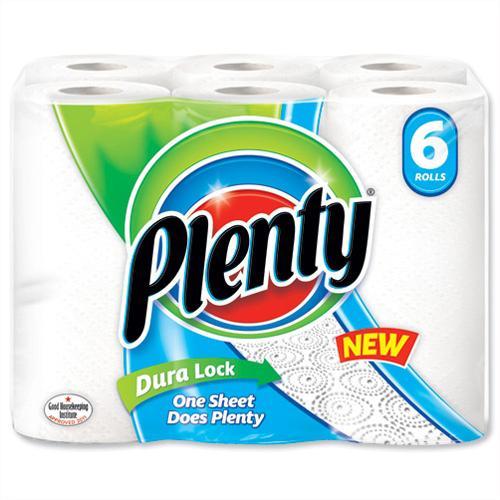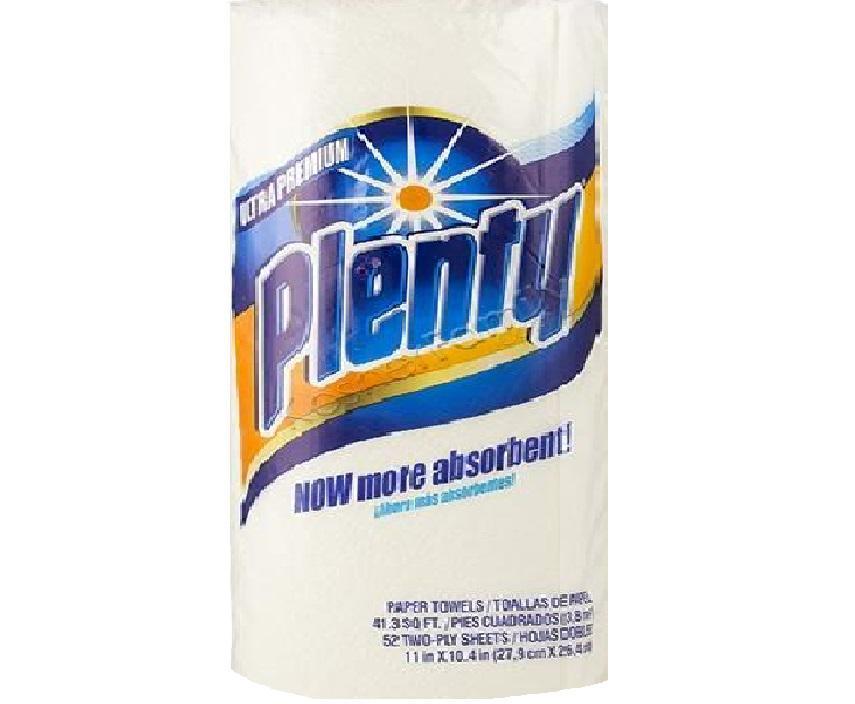The first image is the image on the left, the second image is the image on the right. Evaluate the accuracy of this statement regarding the images: "Right and left images show paper towel packs with blue and orange colors on the packaging, all packs feature a sunburst, and at least one features a red plus-sign.". Is it true? Answer yes or no. No. 